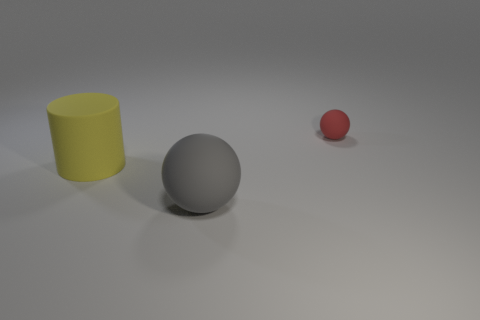There is another yellow thing that is the same material as the tiny thing; what shape is it?
Offer a terse response. Cylinder. How many other yellow rubber objects have the same size as the yellow matte thing?
Your answer should be very brief. 0. Are there fewer large yellow rubber cylinders that are to the right of the large rubber ball than big cylinders that are behind the large cylinder?
Your answer should be very brief. No. Is there another tiny red thing of the same shape as the red thing?
Keep it short and to the point. No. Is the shape of the red matte object the same as the large yellow thing?
Make the answer very short. No. How many small things are either yellow cylinders or brown metallic objects?
Provide a short and direct response. 0. Is the number of tiny balls greater than the number of big red rubber cubes?
Make the answer very short. Yes. What size is the gray ball that is made of the same material as the yellow cylinder?
Provide a short and direct response. Large. Is the size of the object that is left of the large sphere the same as the rubber ball in front of the small matte ball?
Provide a succinct answer. Yes. How many things are things that are in front of the red sphere or big gray matte spheres?
Your answer should be very brief. 2. 